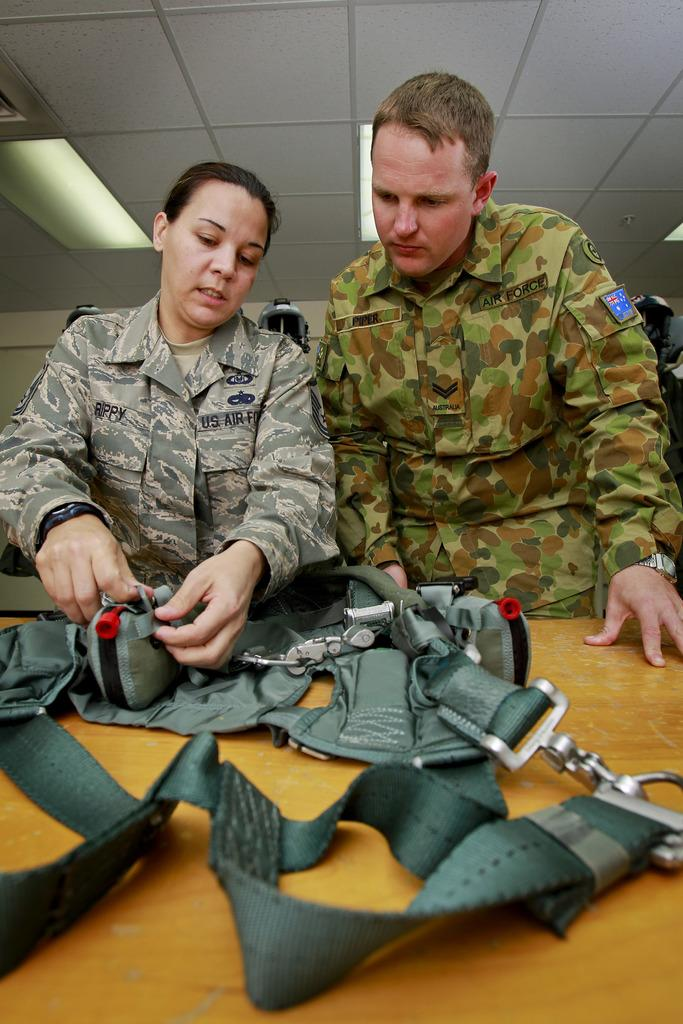What is the woman doing in the image? The woman is checking a bag. What is the woman wearing in the image? The woman is wearing an army dress. Who is beside the woman in the image? There is a man beside the woman. What is the man doing in the image? The man is looking at the woman. What can be seen at the top of the image? There are lights visible at the top of the image. Can you tell me if the woman's friend is saying good-bye to her in the image? There is no indication in the image that the woman has a friend present, nor is there any indication of someone saying good-bye. 